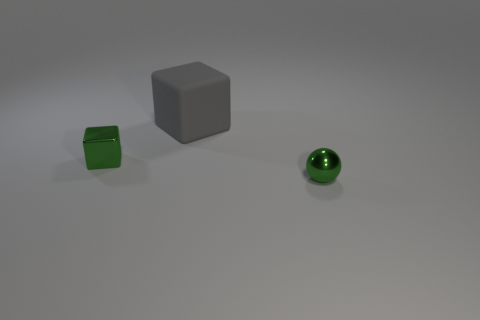Add 3 small metallic objects. How many objects exist? 6 Subtract all cubes. How many objects are left? 1 Subtract all cyan metallic spheres. Subtract all shiny objects. How many objects are left? 1 Add 1 things. How many things are left? 4 Add 1 metallic balls. How many metallic balls exist? 2 Subtract 0 yellow spheres. How many objects are left? 3 